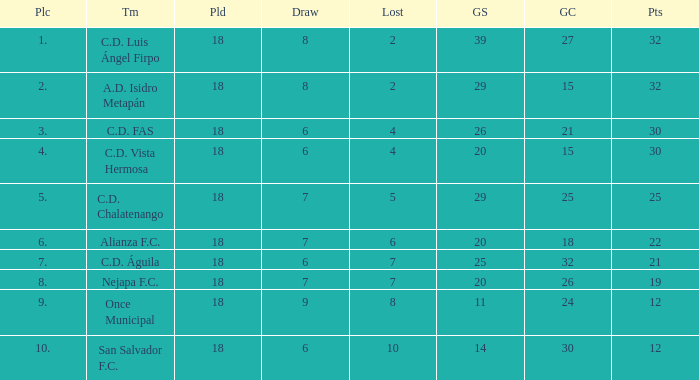What team with a goals conceded smaller than 25, and a place smaller than 3? A.D. Isidro Metapán. 